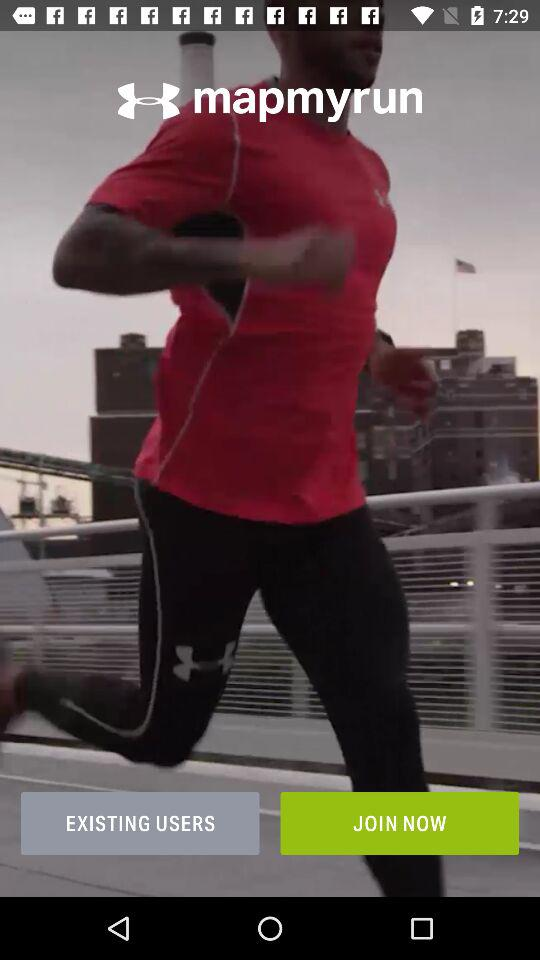With which applications can the user log in?
When the provided information is insufficient, respond with <no answer>. <no answer> 